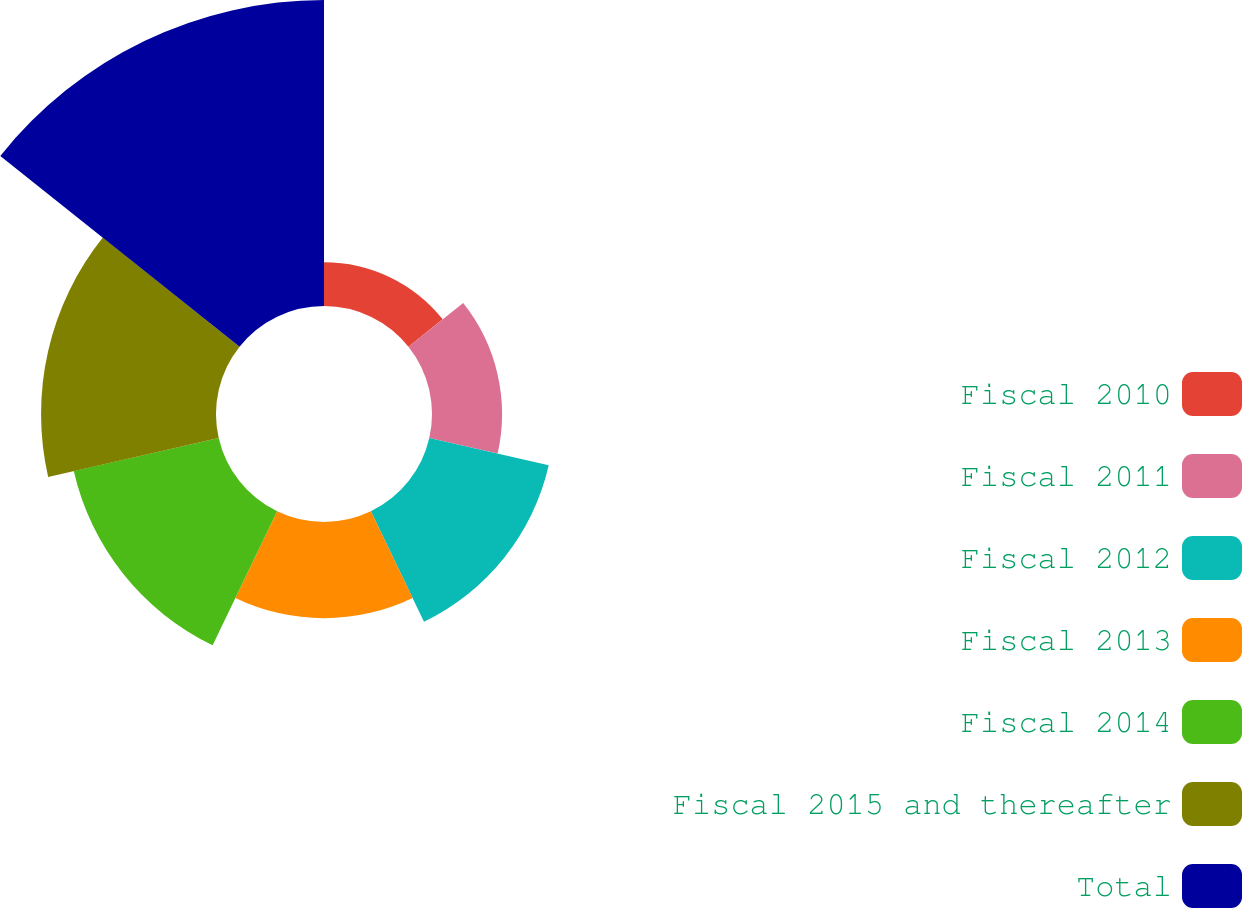Convert chart. <chart><loc_0><loc_0><loc_500><loc_500><pie_chart><fcel>Fiscal 2010<fcel>Fiscal 2011<fcel>Fiscal 2012<fcel>Fiscal 2013<fcel>Fiscal 2014<fcel>Fiscal 2015 and thereafter<fcel>Total<nl><fcel>4.55%<fcel>7.28%<fcel>12.73%<fcel>10.0%<fcel>15.45%<fcel>18.18%<fcel>31.8%<nl></chart> 